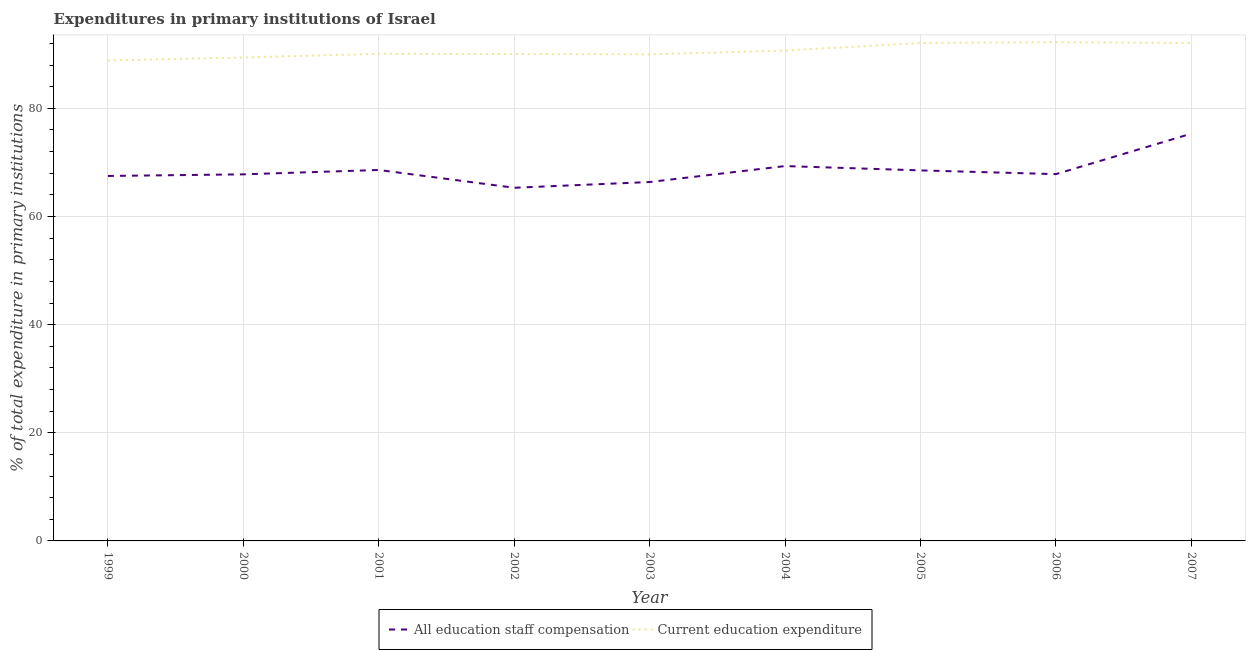Does the line corresponding to expenditure in staff compensation intersect with the line corresponding to expenditure in education?
Your response must be concise. No. Is the number of lines equal to the number of legend labels?
Give a very brief answer. Yes. What is the expenditure in staff compensation in 1999?
Provide a short and direct response. 67.5. Across all years, what is the maximum expenditure in staff compensation?
Offer a terse response. 75.32. Across all years, what is the minimum expenditure in staff compensation?
Keep it short and to the point. 65.31. In which year was the expenditure in education minimum?
Give a very brief answer. 1999. What is the total expenditure in education in the graph?
Offer a very short reply. 815.51. What is the difference between the expenditure in education in 1999 and that in 2004?
Your response must be concise. -1.84. What is the difference between the expenditure in staff compensation in 2004 and the expenditure in education in 2007?
Your answer should be compact. -22.76. What is the average expenditure in staff compensation per year?
Give a very brief answer. 68.51. In the year 2002, what is the difference between the expenditure in staff compensation and expenditure in education?
Give a very brief answer. -24.72. In how many years, is the expenditure in staff compensation greater than 24 %?
Provide a short and direct response. 9. What is the ratio of the expenditure in education in 1999 to that in 2006?
Keep it short and to the point. 0.96. Is the expenditure in education in 2003 less than that in 2006?
Offer a very short reply. Yes. Is the difference between the expenditure in education in 2004 and 2006 greater than the difference between the expenditure in staff compensation in 2004 and 2006?
Offer a very short reply. No. What is the difference between the highest and the second highest expenditure in education?
Your answer should be very brief. 0.16. What is the difference between the highest and the lowest expenditure in education?
Make the answer very short. 3.38. Is the sum of the expenditure in education in 2001 and 2006 greater than the maximum expenditure in staff compensation across all years?
Provide a short and direct response. Yes. Does the expenditure in education monotonically increase over the years?
Your answer should be very brief. No. How many years are there in the graph?
Provide a succinct answer. 9. What is the difference between two consecutive major ticks on the Y-axis?
Give a very brief answer. 20. Are the values on the major ticks of Y-axis written in scientific E-notation?
Keep it short and to the point. No. Where does the legend appear in the graph?
Give a very brief answer. Bottom center. What is the title of the graph?
Provide a succinct answer. Expenditures in primary institutions of Israel. What is the label or title of the Y-axis?
Make the answer very short. % of total expenditure in primary institutions. What is the % of total expenditure in primary institutions in All education staff compensation in 1999?
Your answer should be very brief. 67.5. What is the % of total expenditure in primary institutions of Current education expenditure in 1999?
Your answer should be compact. 88.86. What is the % of total expenditure in primary institutions in All education staff compensation in 2000?
Ensure brevity in your answer.  67.8. What is the % of total expenditure in primary institutions of Current education expenditure in 2000?
Provide a succinct answer. 89.41. What is the % of total expenditure in primary institutions in All education staff compensation in 2001?
Give a very brief answer. 68.61. What is the % of total expenditure in primary institutions of Current education expenditure in 2001?
Provide a short and direct response. 90.1. What is the % of total expenditure in primary institutions in All education staff compensation in 2002?
Give a very brief answer. 65.31. What is the % of total expenditure in primary institutions in Current education expenditure in 2002?
Give a very brief answer. 90.03. What is the % of total expenditure in primary institutions of All education staff compensation in 2003?
Offer a very short reply. 66.38. What is the % of total expenditure in primary institutions of Current education expenditure in 2003?
Keep it short and to the point. 89.99. What is the % of total expenditure in primary institutions in All education staff compensation in 2004?
Your answer should be compact. 69.33. What is the % of total expenditure in primary institutions in Current education expenditure in 2004?
Provide a short and direct response. 90.7. What is the % of total expenditure in primary institutions of All education staff compensation in 2005?
Give a very brief answer. 68.53. What is the % of total expenditure in primary institutions of Current education expenditure in 2005?
Your answer should be very brief. 92.09. What is the % of total expenditure in primary institutions in All education staff compensation in 2006?
Offer a very short reply. 67.84. What is the % of total expenditure in primary institutions in Current education expenditure in 2006?
Ensure brevity in your answer.  92.25. What is the % of total expenditure in primary institutions in All education staff compensation in 2007?
Keep it short and to the point. 75.32. What is the % of total expenditure in primary institutions of Current education expenditure in 2007?
Offer a very short reply. 92.08. Across all years, what is the maximum % of total expenditure in primary institutions of All education staff compensation?
Provide a succinct answer. 75.32. Across all years, what is the maximum % of total expenditure in primary institutions in Current education expenditure?
Make the answer very short. 92.25. Across all years, what is the minimum % of total expenditure in primary institutions of All education staff compensation?
Offer a terse response. 65.31. Across all years, what is the minimum % of total expenditure in primary institutions of Current education expenditure?
Give a very brief answer. 88.86. What is the total % of total expenditure in primary institutions of All education staff compensation in the graph?
Provide a short and direct response. 616.62. What is the total % of total expenditure in primary institutions of Current education expenditure in the graph?
Ensure brevity in your answer.  815.51. What is the difference between the % of total expenditure in primary institutions in All education staff compensation in 1999 and that in 2000?
Your answer should be compact. -0.3. What is the difference between the % of total expenditure in primary institutions of Current education expenditure in 1999 and that in 2000?
Ensure brevity in your answer.  -0.55. What is the difference between the % of total expenditure in primary institutions in All education staff compensation in 1999 and that in 2001?
Keep it short and to the point. -1.11. What is the difference between the % of total expenditure in primary institutions in Current education expenditure in 1999 and that in 2001?
Your answer should be compact. -1.24. What is the difference between the % of total expenditure in primary institutions in All education staff compensation in 1999 and that in 2002?
Provide a short and direct response. 2.18. What is the difference between the % of total expenditure in primary institutions in Current education expenditure in 1999 and that in 2002?
Offer a very short reply. -1.17. What is the difference between the % of total expenditure in primary institutions in All education staff compensation in 1999 and that in 2003?
Give a very brief answer. 1.12. What is the difference between the % of total expenditure in primary institutions in Current education expenditure in 1999 and that in 2003?
Ensure brevity in your answer.  -1.13. What is the difference between the % of total expenditure in primary institutions of All education staff compensation in 1999 and that in 2004?
Your response must be concise. -1.83. What is the difference between the % of total expenditure in primary institutions of Current education expenditure in 1999 and that in 2004?
Provide a short and direct response. -1.84. What is the difference between the % of total expenditure in primary institutions of All education staff compensation in 1999 and that in 2005?
Make the answer very short. -1.03. What is the difference between the % of total expenditure in primary institutions in Current education expenditure in 1999 and that in 2005?
Offer a very short reply. -3.23. What is the difference between the % of total expenditure in primary institutions in All education staff compensation in 1999 and that in 2006?
Ensure brevity in your answer.  -0.34. What is the difference between the % of total expenditure in primary institutions in Current education expenditure in 1999 and that in 2006?
Offer a very short reply. -3.38. What is the difference between the % of total expenditure in primary institutions in All education staff compensation in 1999 and that in 2007?
Provide a short and direct response. -7.83. What is the difference between the % of total expenditure in primary institutions of Current education expenditure in 1999 and that in 2007?
Your response must be concise. -3.22. What is the difference between the % of total expenditure in primary institutions of All education staff compensation in 2000 and that in 2001?
Keep it short and to the point. -0.81. What is the difference between the % of total expenditure in primary institutions of Current education expenditure in 2000 and that in 2001?
Provide a succinct answer. -0.69. What is the difference between the % of total expenditure in primary institutions in All education staff compensation in 2000 and that in 2002?
Give a very brief answer. 2.48. What is the difference between the % of total expenditure in primary institutions in Current education expenditure in 2000 and that in 2002?
Keep it short and to the point. -0.63. What is the difference between the % of total expenditure in primary institutions in All education staff compensation in 2000 and that in 2003?
Offer a terse response. 1.42. What is the difference between the % of total expenditure in primary institutions of Current education expenditure in 2000 and that in 2003?
Ensure brevity in your answer.  -0.59. What is the difference between the % of total expenditure in primary institutions in All education staff compensation in 2000 and that in 2004?
Keep it short and to the point. -1.53. What is the difference between the % of total expenditure in primary institutions of Current education expenditure in 2000 and that in 2004?
Provide a succinct answer. -1.29. What is the difference between the % of total expenditure in primary institutions in All education staff compensation in 2000 and that in 2005?
Offer a terse response. -0.73. What is the difference between the % of total expenditure in primary institutions in Current education expenditure in 2000 and that in 2005?
Offer a very short reply. -2.68. What is the difference between the % of total expenditure in primary institutions of All education staff compensation in 2000 and that in 2006?
Offer a terse response. -0.04. What is the difference between the % of total expenditure in primary institutions in Current education expenditure in 2000 and that in 2006?
Your answer should be compact. -2.84. What is the difference between the % of total expenditure in primary institutions in All education staff compensation in 2000 and that in 2007?
Offer a terse response. -7.53. What is the difference between the % of total expenditure in primary institutions of Current education expenditure in 2000 and that in 2007?
Give a very brief answer. -2.68. What is the difference between the % of total expenditure in primary institutions of All education staff compensation in 2001 and that in 2002?
Give a very brief answer. 3.29. What is the difference between the % of total expenditure in primary institutions of Current education expenditure in 2001 and that in 2002?
Your response must be concise. 0.06. What is the difference between the % of total expenditure in primary institutions of All education staff compensation in 2001 and that in 2003?
Ensure brevity in your answer.  2.23. What is the difference between the % of total expenditure in primary institutions in Current education expenditure in 2001 and that in 2003?
Provide a short and direct response. 0.11. What is the difference between the % of total expenditure in primary institutions of All education staff compensation in 2001 and that in 2004?
Your response must be concise. -0.72. What is the difference between the % of total expenditure in primary institutions of Current education expenditure in 2001 and that in 2004?
Provide a short and direct response. -0.6. What is the difference between the % of total expenditure in primary institutions in All education staff compensation in 2001 and that in 2005?
Provide a succinct answer. 0.08. What is the difference between the % of total expenditure in primary institutions of Current education expenditure in 2001 and that in 2005?
Offer a very short reply. -1.99. What is the difference between the % of total expenditure in primary institutions of All education staff compensation in 2001 and that in 2006?
Your answer should be very brief. 0.77. What is the difference between the % of total expenditure in primary institutions in Current education expenditure in 2001 and that in 2006?
Offer a very short reply. -2.15. What is the difference between the % of total expenditure in primary institutions of All education staff compensation in 2001 and that in 2007?
Offer a terse response. -6.72. What is the difference between the % of total expenditure in primary institutions of Current education expenditure in 2001 and that in 2007?
Provide a succinct answer. -1.98. What is the difference between the % of total expenditure in primary institutions of All education staff compensation in 2002 and that in 2003?
Keep it short and to the point. -1.06. What is the difference between the % of total expenditure in primary institutions in Current education expenditure in 2002 and that in 2003?
Give a very brief answer. 0.04. What is the difference between the % of total expenditure in primary institutions in All education staff compensation in 2002 and that in 2004?
Offer a very short reply. -4.01. What is the difference between the % of total expenditure in primary institutions of Current education expenditure in 2002 and that in 2004?
Keep it short and to the point. -0.66. What is the difference between the % of total expenditure in primary institutions of All education staff compensation in 2002 and that in 2005?
Your answer should be very brief. -3.21. What is the difference between the % of total expenditure in primary institutions in Current education expenditure in 2002 and that in 2005?
Your response must be concise. -2.05. What is the difference between the % of total expenditure in primary institutions in All education staff compensation in 2002 and that in 2006?
Your answer should be compact. -2.52. What is the difference between the % of total expenditure in primary institutions of Current education expenditure in 2002 and that in 2006?
Give a very brief answer. -2.21. What is the difference between the % of total expenditure in primary institutions of All education staff compensation in 2002 and that in 2007?
Offer a terse response. -10.01. What is the difference between the % of total expenditure in primary institutions in Current education expenditure in 2002 and that in 2007?
Your answer should be compact. -2.05. What is the difference between the % of total expenditure in primary institutions of All education staff compensation in 2003 and that in 2004?
Ensure brevity in your answer.  -2.95. What is the difference between the % of total expenditure in primary institutions of Current education expenditure in 2003 and that in 2004?
Provide a short and direct response. -0.71. What is the difference between the % of total expenditure in primary institutions of All education staff compensation in 2003 and that in 2005?
Offer a terse response. -2.15. What is the difference between the % of total expenditure in primary institutions in Current education expenditure in 2003 and that in 2005?
Make the answer very short. -2.1. What is the difference between the % of total expenditure in primary institutions in All education staff compensation in 2003 and that in 2006?
Ensure brevity in your answer.  -1.46. What is the difference between the % of total expenditure in primary institutions in Current education expenditure in 2003 and that in 2006?
Make the answer very short. -2.25. What is the difference between the % of total expenditure in primary institutions in All education staff compensation in 2003 and that in 2007?
Your answer should be compact. -8.95. What is the difference between the % of total expenditure in primary institutions in Current education expenditure in 2003 and that in 2007?
Keep it short and to the point. -2.09. What is the difference between the % of total expenditure in primary institutions in All education staff compensation in 2004 and that in 2005?
Keep it short and to the point. 0.8. What is the difference between the % of total expenditure in primary institutions in Current education expenditure in 2004 and that in 2005?
Provide a short and direct response. -1.39. What is the difference between the % of total expenditure in primary institutions of All education staff compensation in 2004 and that in 2006?
Ensure brevity in your answer.  1.49. What is the difference between the % of total expenditure in primary institutions in Current education expenditure in 2004 and that in 2006?
Make the answer very short. -1.55. What is the difference between the % of total expenditure in primary institutions of All education staff compensation in 2004 and that in 2007?
Provide a short and direct response. -6. What is the difference between the % of total expenditure in primary institutions of Current education expenditure in 2004 and that in 2007?
Give a very brief answer. -1.39. What is the difference between the % of total expenditure in primary institutions in All education staff compensation in 2005 and that in 2006?
Offer a terse response. 0.69. What is the difference between the % of total expenditure in primary institutions of Current education expenditure in 2005 and that in 2006?
Keep it short and to the point. -0.16. What is the difference between the % of total expenditure in primary institutions in All education staff compensation in 2005 and that in 2007?
Ensure brevity in your answer.  -6.8. What is the difference between the % of total expenditure in primary institutions in Current education expenditure in 2005 and that in 2007?
Give a very brief answer. 0.01. What is the difference between the % of total expenditure in primary institutions of All education staff compensation in 2006 and that in 2007?
Provide a short and direct response. -7.49. What is the difference between the % of total expenditure in primary institutions in Current education expenditure in 2006 and that in 2007?
Keep it short and to the point. 0.16. What is the difference between the % of total expenditure in primary institutions in All education staff compensation in 1999 and the % of total expenditure in primary institutions in Current education expenditure in 2000?
Your answer should be compact. -21.91. What is the difference between the % of total expenditure in primary institutions in All education staff compensation in 1999 and the % of total expenditure in primary institutions in Current education expenditure in 2001?
Provide a succinct answer. -22.6. What is the difference between the % of total expenditure in primary institutions in All education staff compensation in 1999 and the % of total expenditure in primary institutions in Current education expenditure in 2002?
Keep it short and to the point. -22.54. What is the difference between the % of total expenditure in primary institutions of All education staff compensation in 1999 and the % of total expenditure in primary institutions of Current education expenditure in 2003?
Provide a succinct answer. -22.49. What is the difference between the % of total expenditure in primary institutions of All education staff compensation in 1999 and the % of total expenditure in primary institutions of Current education expenditure in 2004?
Your answer should be compact. -23.2. What is the difference between the % of total expenditure in primary institutions of All education staff compensation in 1999 and the % of total expenditure in primary institutions of Current education expenditure in 2005?
Ensure brevity in your answer.  -24.59. What is the difference between the % of total expenditure in primary institutions in All education staff compensation in 1999 and the % of total expenditure in primary institutions in Current education expenditure in 2006?
Make the answer very short. -24.75. What is the difference between the % of total expenditure in primary institutions in All education staff compensation in 1999 and the % of total expenditure in primary institutions in Current education expenditure in 2007?
Offer a very short reply. -24.58. What is the difference between the % of total expenditure in primary institutions in All education staff compensation in 2000 and the % of total expenditure in primary institutions in Current education expenditure in 2001?
Your answer should be very brief. -22.3. What is the difference between the % of total expenditure in primary institutions of All education staff compensation in 2000 and the % of total expenditure in primary institutions of Current education expenditure in 2002?
Keep it short and to the point. -22.24. What is the difference between the % of total expenditure in primary institutions in All education staff compensation in 2000 and the % of total expenditure in primary institutions in Current education expenditure in 2003?
Your response must be concise. -22.19. What is the difference between the % of total expenditure in primary institutions of All education staff compensation in 2000 and the % of total expenditure in primary institutions of Current education expenditure in 2004?
Your answer should be compact. -22.9. What is the difference between the % of total expenditure in primary institutions of All education staff compensation in 2000 and the % of total expenditure in primary institutions of Current education expenditure in 2005?
Give a very brief answer. -24.29. What is the difference between the % of total expenditure in primary institutions of All education staff compensation in 2000 and the % of total expenditure in primary institutions of Current education expenditure in 2006?
Provide a short and direct response. -24.45. What is the difference between the % of total expenditure in primary institutions of All education staff compensation in 2000 and the % of total expenditure in primary institutions of Current education expenditure in 2007?
Offer a terse response. -24.29. What is the difference between the % of total expenditure in primary institutions in All education staff compensation in 2001 and the % of total expenditure in primary institutions in Current education expenditure in 2002?
Your response must be concise. -21.43. What is the difference between the % of total expenditure in primary institutions in All education staff compensation in 2001 and the % of total expenditure in primary institutions in Current education expenditure in 2003?
Make the answer very short. -21.39. What is the difference between the % of total expenditure in primary institutions in All education staff compensation in 2001 and the % of total expenditure in primary institutions in Current education expenditure in 2004?
Your response must be concise. -22.09. What is the difference between the % of total expenditure in primary institutions of All education staff compensation in 2001 and the % of total expenditure in primary institutions of Current education expenditure in 2005?
Ensure brevity in your answer.  -23.48. What is the difference between the % of total expenditure in primary institutions in All education staff compensation in 2001 and the % of total expenditure in primary institutions in Current education expenditure in 2006?
Offer a very short reply. -23.64. What is the difference between the % of total expenditure in primary institutions in All education staff compensation in 2001 and the % of total expenditure in primary institutions in Current education expenditure in 2007?
Make the answer very short. -23.48. What is the difference between the % of total expenditure in primary institutions of All education staff compensation in 2002 and the % of total expenditure in primary institutions of Current education expenditure in 2003?
Provide a succinct answer. -24.68. What is the difference between the % of total expenditure in primary institutions in All education staff compensation in 2002 and the % of total expenditure in primary institutions in Current education expenditure in 2004?
Provide a short and direct response. -25.38. What is the difference between the % of total expenditure in primary institutions of All education staff compensation in 2002 and the % of total expenditure in primary institutions of Current education expenditure in 2005?
Offer a terse response. -26.77. What is the difference between the % of total expenditure in primary institutions of All education staff compensation in 2002 and the % of total expenditure in primary institutions of Current education expenditure in 2006?
Your response must be concise. -26.93. What is the difference between the % of total expenditure in primary institutions of All education staff compensation in 2002 and the % of total expenditure in primary institutions of Current education expenditure in 2007?
Your answer should be compact. -26.77. What is the difference between the % of total expenditure in primary institutions in All education staff compensation in 2003 and the % of total expenditure in primary institutions in Current education expenditure in 2004?
Provide a short and direct response. -24.32. What is the difference between the % of total expenditure in primary institutions of All education staff compensation in 2003 and the % of total expenditure in primary institutions of Current education expenditure in 2005?
Your answer should be compact. -25.71. What is the difference between the % of total expenditure in primary institutions of All education staff compensation in 2003 and the % of total expenditure in primary institutions of Current education expenditure in 2006?
Make the answer very short. -25.87. What is the difference between the % of total expenditure in primary institutions in All education staff compensation in 2003 and the % of total expenditure in primary institutions in Current education expenditure in 2007?
Provide a succinct answer. -25.71. What is the difference between the % of total expenditure in primary institutions in All education staff compensation in 2004 and the % of total expenditure in primary institutions in Current education expenditure in 2005?
Your response must be concise. -22.76. What is the difference between the % of total expenditure in primary institutions of All education staff compensation in 2004 and the % of total expenditure in primary institutions of Current education expenditure in 2006?
Offer a very short reply. -22.92. What is the difference between the % of total expenditure in primary institutions of All education staff compensation in 2004 and the % of total expenditure in primary institutions of Current education expenditure in 2007?
Provide a short and direct response. -22.76. What is the difference between the % of total expenditure in primary institutions in All education staff compensation in 2005 and the % of total expenditure in primary institutions in Current education expenditure in 2006?
Keep it short and to the point. -23.72. What is the difference between the % of total expenditure in primary institutions in All education staff compensation in 2005 and the % of total expenditure in primary institutions in Current education expenditure in 2007?
Provide a short and direct response. -23.55. What is the difference between the % of total expenditure in primary institutions in All education staff compensation in 2006 and the % of total expenditure in primary institutions in Current education expenditure in 2007?
Your answer should be compact. -24.25. What is the average % of total expenditure in primary institutions of All education staff compensation per year?
Provide a short and direct response. 68.51. What is the average % of total expenditure in primary institutions of Current education expenditure per year?
Your answer should be compact. 90.61. In the year 1999, what is the difference between the % of total expenditure in primary institutions of All education staff compensation and % of total expenditure in primary institutions of Current education expenditure?
Make the answer very short. -21.36. In the year 2000, what is the difference between the % of total expenditure in primary institutions in All education staff compensation and % of total expenditure in primary institutions in Current education expenditure?
Your answer should be compact. -21.61. In the year 2001, what is the difference between the % of total expenditure in primary institutions in All education staff compensation and % of total expenditure in primary institutions in Current education expenditure?
Keep it short and to the point. -21.49. In the year 2002, what is the difference between the % of total expenditure in primary institutions in All education staff compensation and % of total expenditure in primary institutions in Current education expenditure?
Give a very brief answer. -24.72. In the year 2003, what is the difference between the % of total expenditure in primary institutions of All education staff compensation and % of total expenditure in primary institutions of Current education expenditure?
Your answer should be compact. -23.61. In the year 2004, what is the difference between the % of total expenditure in primary institutions in All education staff compensation and % of total expenditure in primary institutions in Current education expenditure?
Offer a terse response. -21.37. In the year 2005, what is the difference between the % of total expenditure in primary institutions in All education staff compensation and % of total expenditure in primary institutions in Current education expenditure?
Keep it short and to the point. -23.56. In the year 2006, what is the difference between the % of total expenditure in primary institutions of All education staff compensation and % of total expenditure in primary institutions of Current education expenditure?
Your answer should be very brief. -24.41. In the year 2007, what is the difference between the % of total expenditure in primary institutions of All education staff compensation and % of total expenditure in primary institutions of Current education expenditure?
Give a very brief answer. -16.76. What is the ratio of the % of total expenditure in primary institutions of All education staff compensation in 1999 to that in 2001?
Your response must be concise. 0.98. What is the ratio of the % of total expenditure in primary institutions of Current education expenditure in 1999 to that in 2001?
Your answer should be compact. 0.99. What is the ratio of the % of total expenditure in primary institutions in All education staff compensation in 1999 to that in 2002?
Make the answer very short. 1.03. What is the ratio of the % of total expenditure in primary institutions of All education staff compensation in 1999 to that in 2003?
Offer a very short reply. 1.02. What is the ratio of the % of total expenditure in primary institutions of Current education expenditure in 1999 to that in 2003?
Make the answer very short. 0.99. What is the ratio of the % of total expenditure in primary institutions of All education staff compensation in 1999 to that in 2004?
Your answer should be compact. 0.97. What is the ratio of the % of total expenditure in primary institutions of Current education expenditure in 1999 to that in 2004?
Provide a short and direct response. 0.98. What is the ratio of the % of total expenditure in primary institutions of All education staff compensation in 1999 to that in 2005?
Your answer should be very brief. 0.98. What is the ratio of the % of total expenditure in primary institutions of Current education expenditure in 1999 to that in 2005?
Offer a terse response. 0.96. What is the ratio of the % of total expenditure in primary institutions in All education staff compensation in 1999 to that in 2006?
Provide a succinct answer. 0.99. What is the ratio of the % of total expenditure in primary institutions of Current education expenditure in 1999 to that in 2006?
Provide a succinct answer. 0.96. What is the ratio of the % of total expenditure in primary institutions in All education staff compensation in 1999 to that in 2007?
Make the answer very short. 0.9. What is the ratio of the % of total expenditure in primary institutions of All education staff compensation in 2000 to that in 2002?
Your response must be concise. 1.04. What is the ratio of the % of total expenditure in primary institutions in Current education expenditure in 2000 to that in 2002?
Your answer should be very brief. 0.99. What is the ratio of the % of total expenditure in primary institutions of All education staff compensation in 2000 to that in 2003?
Keep it short and to the point. 1.02. What is the ratio of the % of total expenditure in primary institutions of Current education expenditure in 2000 to that in 2003?
Your response must be concise. 0.99. What is the ratio of the % of total expenditure in primary institutions in All education staff compensation in 2000 to that in 2004?
Ensure brevity in your answer.  0.98. What is the ratio of the % of total expenditure in primary institutions of Current education expenditure in 2000 to that in 2004?
Your response must be concise. 0.99. What is the ratio of the % of total expenditure in primary institutions in All education staff compensation in 2000 to that in 2005?
Offer a terse response. 0.99. What is the ratio of the % of total expenditure in primary institutions in Current education expenditure in 2000 to that in 2005?
Ensure brevity in your answer.  0.97. What is the ratio of the % of total expenditure in primary institutions of Current education expenditure in 2000 to that in 2006?
Your response must be concise. 0.97. What is the ratio of the % of total expenditure in primary institutions in All education staff compensation in 2000 to that in 2007?
Your answer should be compact. 0.9. What is the ratio of the % of total expenditure in primary institutions in Current education expenditure in 2000 to that in 2007?
Offer a terse response. 0.97. What is the ratio of the % of total expenditure in primary institutions of All education staff compensation in 2001 to that in 2002?
Your answer should be compact. 1.05. What is the ratio of the % of total expenditure in primary institutions of All education staff compensation in 2001 to that in 2003?
Your answer should be very brief. 1.03. What is the ratio of the % of total expenditure in primary institutions of Current education expenditure in 2001 to that in 2003?
Offer a terse response. 1. What is the ratio of the % of total expenditure in primary institutions in All education staff compensation in 2001 to that in 2004?
Ensure brevity in your answer.  0.99. What is the ratio of the % of total expenditure in primary institutions of Current education expenditure in 2001 to that in 2004?
Make the answer very short. 0.99. What is the ratio of the % of total expenditure in primary institutions in All education staff compensation in 2001 to that in 2005?
Your answer should be compact. 1. What is the ratio of the % of total expenditure in primary institutions of Current education expenditure in 2001 to that in 2005?
Give a very brief answer. 0.98. What is the ratio of the % of total expenditure in primary institutions of All education staff compensation in 2001 to that in 2006?
Your response must be concise. 1.01. What is the ratio of the % of total expenditure in primary institutions in Current education expenditure in 2001 to that in 2006?
Make the answer very short. 0.98. What is the ratio of the % of total expenditure in primary institutions of All education staff compensation in 2001 to that in 2007?
Ensure brevity in your answer.  0.91. What is the ratio of the % of total expenditure in primary institutions of Current education expenditure in 2001 to that in 2007?
Offer a very short reply. 0.98. What is the ratio of the % of total expenditure in primary institutions in All education staff compensation in 2002 to that in 2003?
Give a very brief answer. 0.98. What is the ratio of the % of total expenditure in primary institutions in Current education expenditure in 2002 to that in 2003?
Provide a succinct answer. 1. What is the ratio of the % of total expenditure in primary institutions in All education staff compensation in 2002 to that in 2004?
Your response must be concise. 0.94. What is the ratio of the % of total expenditure in primary institutions in All education staff compensation in 2002 to that in 2005?
Ensure brevity in your answer.  0.95. What is the ratio of the % of total expenditure in primary institutions of Current education expenditure in 2002 to that in 2005?
Give a very brief answer. 0.98. What is the ratio of the % of total expenditure in primary institutions of All education staff compensation in 2002 to that in 2006?
Make the answer very short. 0.96. What is the ratio of the % of total expenditure in primary institutions of Current education expenditure in 2002 to that in 2006?
Keep it short and to the point. 0.98. What is the ratio of the % of total expenditure in primary institutions in All education staff compensation in 2002 to that in 2007?
Your answer should be compact. 0.87. What is the ratio of the % of total expenditure in primary institutions in Current education expenditure in 2002 to that in 2007?
Ensure brevity in your answer.  0.98. What is the ratio of the % of total expenditure in primary institutions of All education staff compensation in 2003 to that in 2004?
Provide a short and direct response. 0.96. What is the ratio of the % of total expenditure in primary institutions in Current education expenditure in 2003 to that in 2004?
Ensure brevity in your answer.  0.99. What is the ratio of the % of total expenditure in primary institutions of All education staff compensation in 2003 to that in 2005?
Your answer should be very brief. 0.97. What is the ratio of the % of total expenditure in primary institutions in Current education expenditure in 2003 to that in 2005?
Your response must be concise. 0.98. What is the ratio of the % of total expenditure in primary institutions in All education staff compensation in 2003 to that in 2006?
Your answer should be very brief. 0.98. What is the ratio of the % of total expenditure in primary institutions of Current education expenditure in 2003 to that in 2006?
Offer a terse response. 0.98. What is the ratio of the % of total expenditure in primary institutions in All education staff compensation in 2003 to that in 2007?
Provide a short and direct response. 0.88. What is the ratio of the % of total expenditure in primary institutions of Current education expenditure in 2003 to that in 2007?
Offer a very short reply. 0.98. What is the ratio of the % of total expenditure in primary institutions in All education staff compensation in 2004 to that in 2005?
Provide a short and direct response. 1.01. What is the ratio of the % of total expenditure in primary institutions in Current education expenditure in 2004 to that in 2005?
Your response must be concise. 0.98. What is the ratio of the % of total expenditure in primary institutions of All education staff compensation in 2004 to that in 2006?
Give a very brief answer. 1.02. What is the ratio of the % of total expenditure in primary institutions in Current education expenditure in 2004 to that in 2006?
Offer a terse response. 0.98. What is the ratio of the % of total expenditure in primary institutions of All education staff compensation in 2004 to that in 2007?
Your answer should be very brief. 0.92. What is the ratio of the % of total expenditure in primary institutions of Current education expenditure in 2004 to that in 2007?
Your answer should be very brief. 0.98. What is the ratio of the % of total expenditure in primary institutions of All education staff compensation in 2005 to that in 2006?
Your answer should be compact. 1.01. What is the ratio of the % of total expenditure in primary institutions in All education staff compensation in 2005 to that in 2007?
Your answer should be compact. 0.91. What is the ratio of the % of total expenditure in primary institutions in All education staff compensation in 2006 to that in 2007?
Give a very brief answer. 0.9. What is the difference between the highest and the second highest % of total expenditure in primary institutions in All education staff compensation?
Make the answer very short. 6. What is the difference between the highest and the second highest % of total expenditure in primary institutions in Current education expenditure?
Provide a short and direct response. 0.16. What is the difference between the highest and the lowest % of total expenditure in primary institutions in All education staff compensation?
Provide a succinct answer. 10.01. What is the difference between the highest and the lowest % of total expenditure in primary institutions of Current education expenditure?
Make the answer very short. 3.38. 